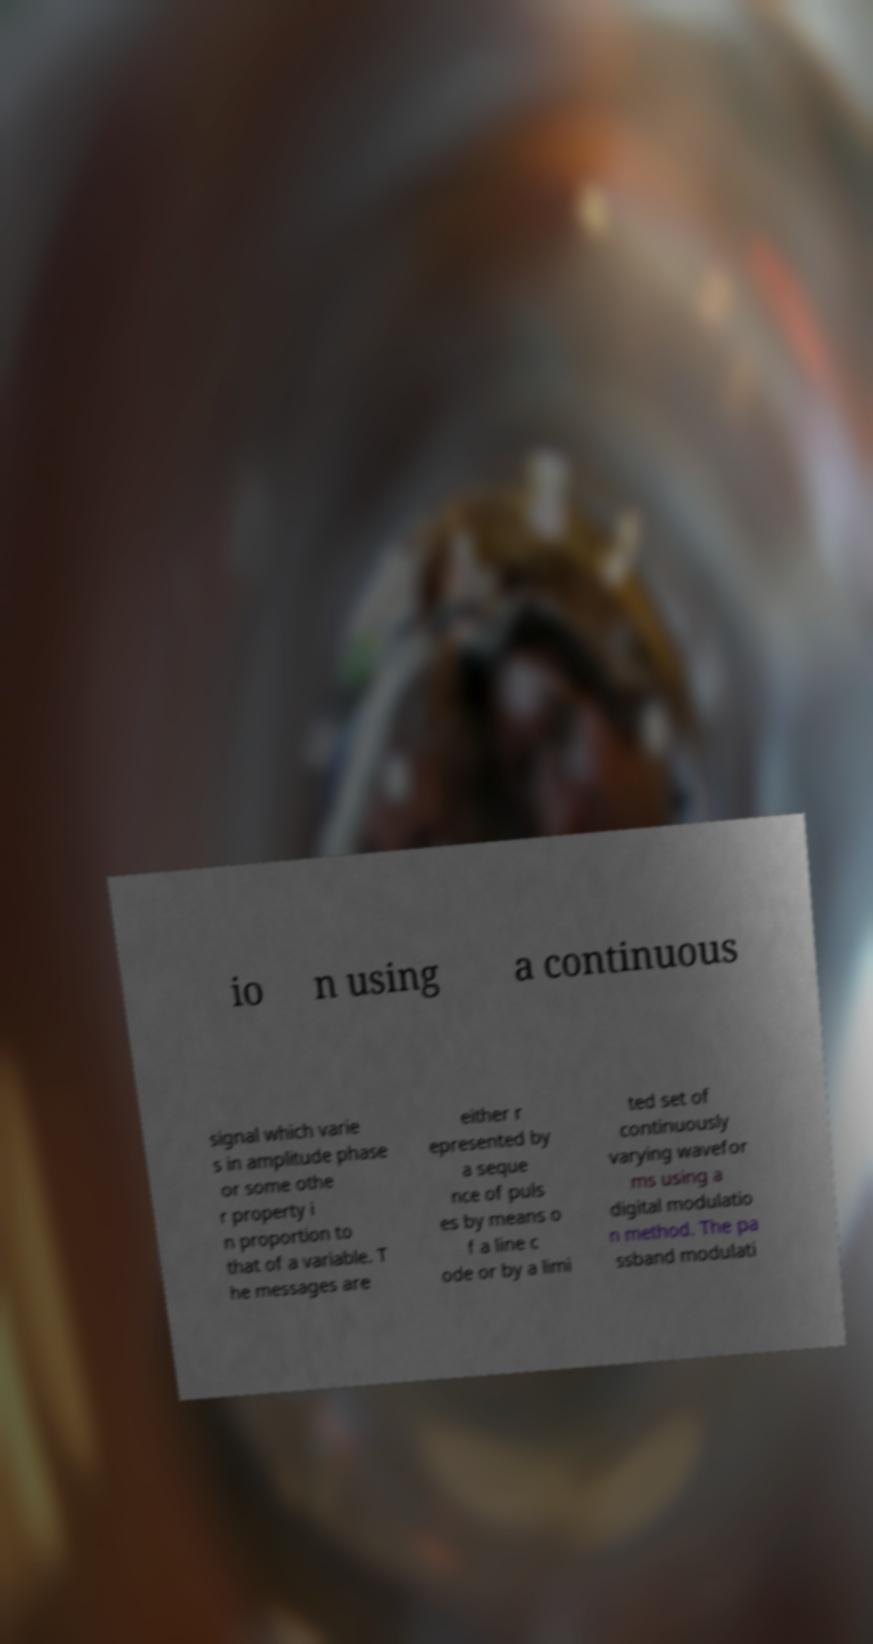What messages or text are displayed in this image? I need them in a readable, typed format. io n using a continuous signal which varie s in amplitude phase or some othe r property i n proportion to that of a variable. T he messages are either r epresented by a seque nce of puls es by means o f a line c ode or by a limi ted set of continuously varying wavefor ms using a digital modulatio n method. The pa ssband modulati 